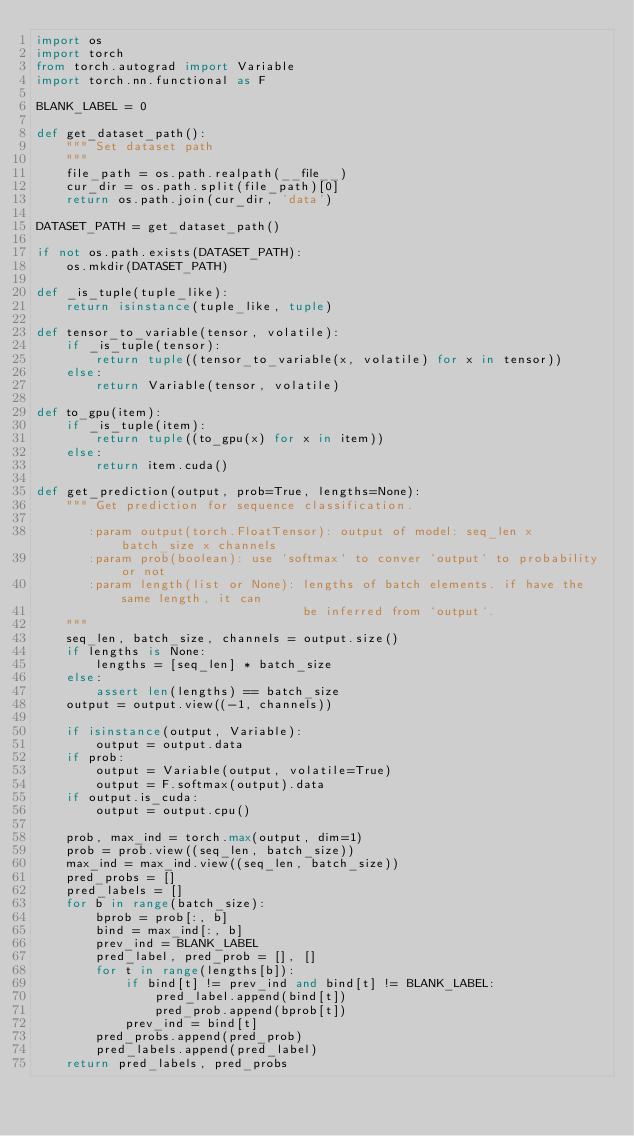Convert code to text. <code><loc_0><loc_0><loc_500><loc_500><_Python_>import os
import torch
from torch.autograd import Variable
import torch.nn.functional as F

BLANK_LABEL = 0

def get_dataset_path():
    """ Set dataset path
    """
    file_path = os.path.realpath(__file__)
    cur_dir = os.path.split(file_path)[0]
    return os.path.join(cur_dir, 'data')

DATASET_PATH = get_dataset_path()

if not os.path.exists(DATASET_PATH):
    os.mkdir(DATASET_PATH)

def _is_tuple(tuple_like):
    return isinstance(tuple_like, tuple)

def tensor_to_variable(tensor, volatile):
    if _is_tuple(tensor):
        return tuple((tensor_to_variable(x, volatile) for x in tensor))
    else:
        return Variable(tensor, volatile)

def to_gpu(item):
    if _is_tuple(item):
        return tuple((to_gpu(x) for x in item))
    else:
        return item.cuda()

def get_prediction(output, prob=True, lengths=None):
    """ Get prediction for sequence classification.

       :param output(torch.FloatTensor): output of model: seq_len x batch_size x channels
       :param prob(boolean): use `softmax` to conver `output` to probability or not
       :param length(list or None): lengths of batch elements. if have the same length, it can
                                    be inferred from `output`.
    """
    seq_len, batch_size, channels = output.size()
    if lengths is None:
        lengths = [seq_len] * batch_size
    else:
        assert len(lengths) == batch_size
    output = output.view((-1, channels))

    if isinstance(output, Variable):
        output = output.data
    if prob:
        output = Variable(output, volatile=True)
        output = F.softmax(output).data
    if output.is_cuda:
        output = output.cpu()

    prob, max_ind = torch.max(output, dim=1)
    prob = prob.view((seq_len, batch_size))
    max_ind = max_ind.view((seq_len, batch_size))
    pred_probs = []
    pred_labels = []
    for b in range(batch_size):
        bprob = prob[:, b]
        bind = max_ind[:, b]
        prev_ind = BLANK_LABEL
        pred_label, pred_prob = [], []
        for t in range(lengths[b]):
            if bind[t] != prev_ind and bind[t] != BLANK_LABEL:
                pred_label.append(bind[t])
                pred_prob.append(bprob[t])
            prev_ind = bind[t]
        pred_probs.append(pred_prob)
        pred_labels.append(pred_label)
    return pred_labels, pred_probs

    
</code> 